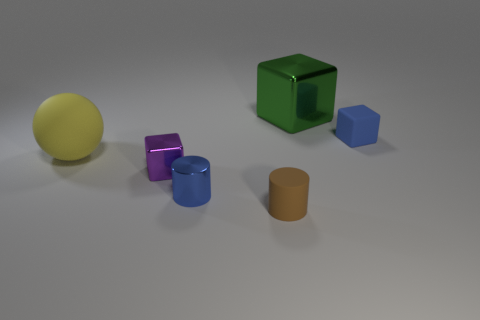Add 1 large matte spheres. How many objects exist? 7 Subtract all spheres. How many objects are left? 5 Add 1 green things. How many green things are left? 2 Add 1 large green shiny things. How many large green shiny things exist? 2 Subtract 0 red balls. How many objects are left? 6 Subtract all green shiny cubes. Subtract all big objects. How many objects are left? 3 